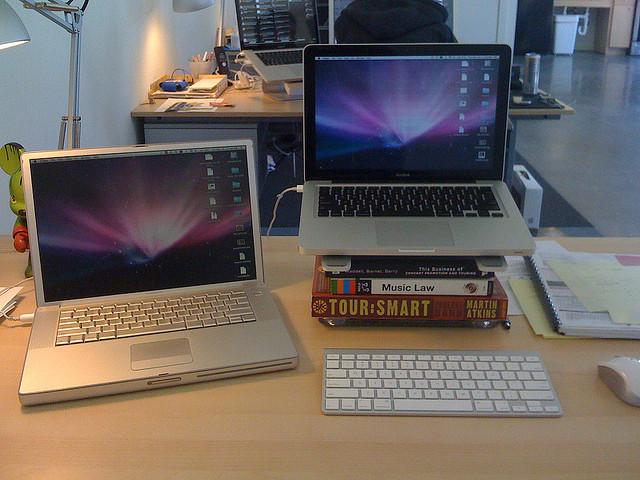Is this an Apple product?
Short answer required. Yes. How many closed laptops?
Answer briefly. 0. Are there eyeglasses in this picture?
Short answer required. No. What are the computers on top of?
Give a very brief answer. Books. How many keyboards can be seen?
Be succinct. 3. How many windows are open on both computers?
Answer briefly. 0. What is the brand of the laptop?
Answer briefly. Apple. What operating system do these computers run?
Be succinct. Windows. Are the laptops on?
Write a very short answer. Yes. Is the book under the laptop?
Write a very short answer. Yes. Is there a mouse pad?
Keep it brief. No. Is there a wireless keyboard attached?
Answer briefly. Yes. Is this a MAC?
Short answer required. Yes. How many screens are on?
Be succinct. 3. What kind of law is the book?
Keep it brief. Music. What letter is in the upper right corner of the left computer?
Concise answer only. Unknown. What color is the laptop on the right?
Give a very brief answer. Silver. Is there a champagne bottle on the desk?
Concise answer only. No. 